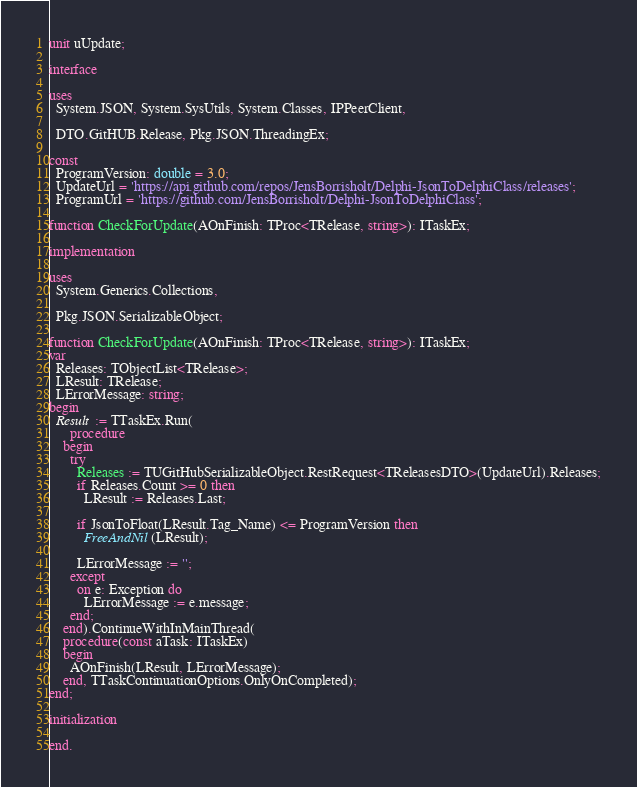Convert code to text. <code><loc_0><loc_0><loc_500><loc_500><_Pascal_>unit uUpdate;

interface

uses
  System.JSON, System.SysUtils, System.Classes, IPPeerClient,

  DTO.GitHUB.Release, Pkg.JSON.ThreadingEx;

const
  ProgramVersion: double = 3.0;
  UpdateUrl = 'https://api.github.com/repos/JensBorrisholt/Delphi-JsonToDelphiClass/releases';
  ProgramUrl = 'https://github.com/JensBorrisholt/Delphi-JsonToDelphiClass';

function CheckForUpdate(AOnFinish: TProc<TRelease, string>): ITaskEx;

implementation

uses
  System.Generics.Collections,

  Pkg.JSON.SerializableObject;

function CheckForUpdate(AOnFinish: TProc<TRelease, string>): ITaskEx;
var
  Releases: TObjectList<TRelease>;
  LResult: TRelease;
  LErrorMessage: string;
begin
  Result := TTaskEx.Run(
      procedure
    begin
      try
        Releases := TUGitHubSerializableObject.RestRequest<TReleasesDTO>(UpdateUrl).Releases;
        if Releases.Count >= 0 then
          LResult := Releases.Last;

        if JsonToFloat(LResult.Tag_Name) <= ProgramVersion then
          FreeAndNil(LResult);

        LErrorMessage := '';
      except
        on e: Exception do
          LErrorMessage := e.message;
      end;
    end).ContinueWithInMainThread(
    procedure(const aTask: ITaskEx)
    begin
      AOnFinish(LResult, LErrorMessage);
    end, TTaskContinuationOptions.OnlyOnCompleted);
end;

initialization

end.
</code> 